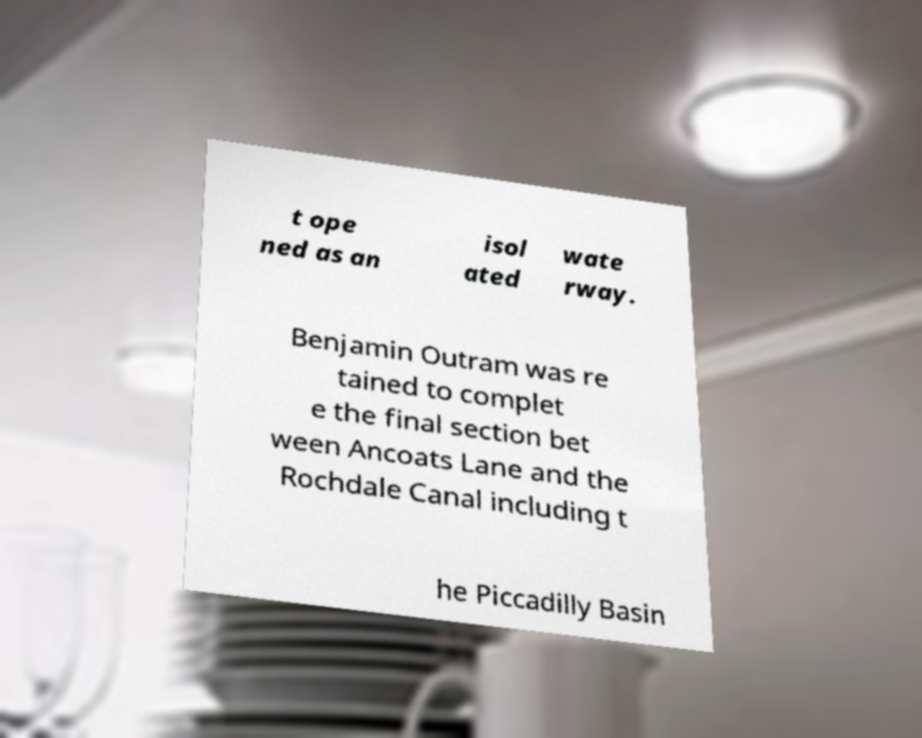Please read and relay the text visible in this image. What does it say? t ope ned as an isol ated wate rway. Benjamin Outram was re tained to complet e the final section bet ween Ancoats Lane and the Rochdale Canal including t he Piccadilly Basin 